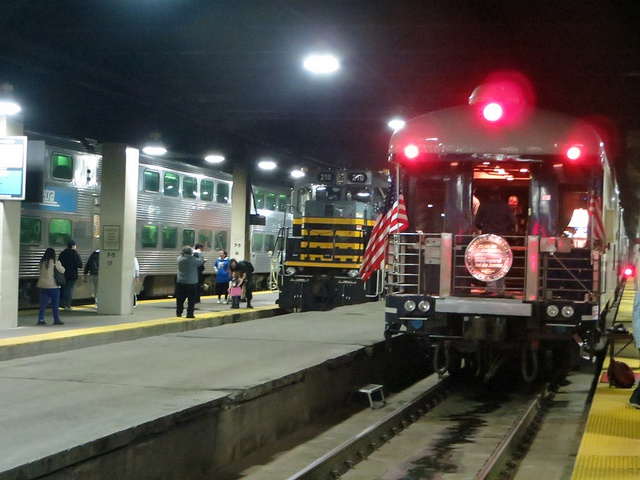Describe the objects in this image and their specific colors. I can see train in black, maroon, brown, and gray tones, train in black, gray, darkgray, and white tones, train in black, gray, darkgray, and olive tones, people in black, gray, purple, and darkgray tones, and people in black, gray, and navy tones in this image. 